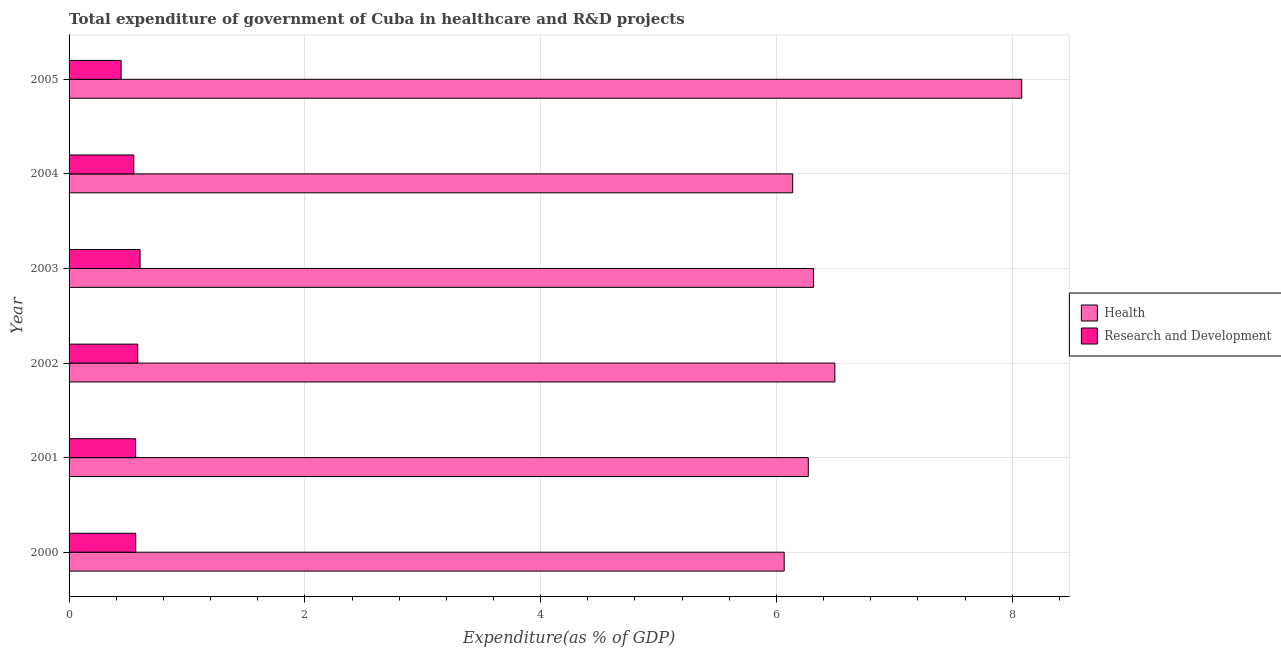How many different coloured bars are there?
Your answer should be very brief. 2. How many groups of bars are there?
Offer a terse response. 6. Are the number of bars on each tick of the Y-axis equal?
Offer a very short reply. Yes. How many bars are there on the 1st tick from the bottom?
Offer a very short reply. 2. What is the label of the 5th group of bars from the top?
Offer a terse response. 2001. What is the expenditure in r&d in 2000?
Provide a short and direct response. 0.57. Across all years, what is the maximum expenditure in r&d?
Your answer should be compact. 0.6. Across all years, what is the minimum expenditure in healthcare?
Ensure brevity in your answer.  6.07. In which year was the expenditure in r&d minimum?
Offer a very short reply. 2005. What is the total expenditure in healthcare in the graph?
Your answer should be compact. 39.36. What is the difference between the expenditure in r&d in 2000 and that in 2004?
Provide a succinct answer. 0.02. What is the difference between the expenditure in healthcare in 2000 and the expenditure in r&d in 2001?
Provide a succinct answer. 5.5. What is the average expenditure in r&d per year?
Provide a succinct answer. 0.55. In the year 2005, what is the difference between the expenditure in r&d and expenditure in healthcare?
Your answer should be compact. -7.64. In how many years, is the expenditure in r&d greater than 2.8 %?
Keep it short and to the point. 0. What is the difference between the highest and the second highest expenditure in healthcare?
Ensure brevity in your answer.  1.58. What is the difference between the highest and the lowest expenditure in healthcare?
Offer a very short reply. 2.01. Is the sum of the expenditure in healthcare in 2001 and 2003 greater than the maximum expenditure in r&d across all years?
Provide a succinct answer. Yes. What does the 2nd bar from the top in 2000 represents?
Your answer should be compact. Health. What does the 2nd bar from the bottom in 2004 represents?
Ensure brevity in your answer.  Research and Development. How many bars are there?
Offer a terse response. 12. What is the difference between two consecutive major ticks on the X-axis?
Offer a terse response. 2. Where does the legend appear in the graph?
Make the answer very short. Center right. How are the legend labels stacked?
Ensure brevity in your answer.  Vertical. What is the title of the graph?
Give a very brief answer. Total expenditure of government of Cuba in healthcare and R&D projects. Does "UN agencies" appear as one of the legend labels in the graph?
Provide a succinct answer. No. What is the label or title of the X-axis?
Ensure brevity in your answer.  Expenditure(as % of GDP). What is the Expenditure(as % of GDP) of Health in 2000?
Ensure brevity in your answer.  6.07. What is the Expenditure(as % of GDP) of Research and Development in 2000?
Offer a very short reply. 0.57. What is the Expenditure(as % of GDP) of Health in 2001?
Offer a very short reply. 6.27. What is the Expenditure(as % of GDP) in Research and Development in 2001?
Make the answer very short. 0.56. What is the Expenditure(as % of GDP) in Health in 2002?
Ensure brevity in your answer.  6.5. What is the Expenditure(as % of GDP) of Research and Development in 2002?
Make the answer very short. 0.58. What is the Expenditure(as % of GDP) of Health in 2003?
Keep it short and to the point. 6.31. What is the Expenditure(as % of GDP) of Research and Development in 2003?
Offer a terse response. 0.6. What is the Expenditure(as % of GDP) of Health in 2004?
Your answer should be compact. 6.14. What is the Expenditure(as % of GDP) of Research and Development in 2004?
Offer a terse response. 0.55. What is the Expenditure(as % of GDP) in Health in 2005?
Ensure brevity in your answer.  8.08. What is the Expenditure(as % of GDP) of Research and Development in 2005?
Offer a very short reply. 0.44. Across all years, what is the maximum Expenditure(as % of GDP) of Health?
Your answer should be very brief. 8.08. Across all years, what is the maximum Expenditure(as % of GDP) in Research and Development?
Your response must be concise. 0.6. Across all years, what is the minimum Expenditure(as % of GDP) in Health?
Keep it short and to the point. 6.07. Across all years, what is the minimum Expenditure(as % of GDP) of Research and Development?
Your answer should be very brief. 0.44. What is the total Expenditure(as % of GDP) of Health in the graph?
Make the answer very short. 39.36. What is the total Expenditure(as % of GDP) of Research and Development in the graph?
Your answer should be compact. 3.31. What is the difference between the Expenditure(as % of GDP) in Health in 2000 and that in 2001?
Your answer should be very brief. -0.2. What is the difference between the Expenditure(as % of GDP) of Research and Development in 2000 and that in 2001?
Your answer should be compact. 0. What is the difference between the Expenditure(as % of GDP) in Health in 2000 and that in 2002?
Provide a short and direct response. -0.43. What is the difference between the Expenditure(as % of GDP) in Research and Development in 2000 and that in 2002?
Make the answer very short. -0.02. What is the difference between the Expenditure(as % of GDP) in Health in 2000 and that in 2003?
Provide a succinct answer. -0.25. What is the difference between the Expenditure(as % of GDP) of Research and Development in 2000 and that in 2003?
Keep it short and to the point. -0.04. What is the difference between the Expenditure(as % of GDP) in Health in 2000 and that in 2004?
Give a very brief answer. -0.07. What is the difference between the Expenditure(as % of GDP) in Research and Development in 2000 and that in 2004?
Offer a very short reply. 0.02. What is the difference between the Expenditure(as % of GDP) in Health in 2000 and that in 2005?
Ensure brevity in your answer.  -2.01. What is the difference between the Expenditure(as % of GDP) of Research and Development in 2000 and that in 2005?
Give a very brief answer. 0.12. What is the difference between the Expenditure(as % of GDP) of Health in 2001 and that in 2002?
Provide a succinct answer. -0.23. What is the difference between the Expenditure(as % of GDP) of Research and Development in 2001 and that in 2002?
Your answer should be very brief. -0.02. What is the difference between the Expenditure(as % of GDP) of Health in 2001 and that in 2003?
Your answer should be very brief. -0.04. What is the difference between the Expenditure(as % of GDP) of Research and Development in 2001 and that in 2003?
Offer a very short reply. -0.04. What is the difference between the Expenditure(as % of GDP) in Health in 2001 and that in 2004?
Give a very brief answer. 0.13. What is the difference between the Expenditure(as % of GDP) in Research and Development in 2001 and that in 2004?
Ensure brevity in your answer.  0.02. What is the difference between the Expenditure(as % of GDP) of Health in 2001 and that in 2005?
Your answer should be compact. -1.81. What is the difference between the Expenditure(as % of GDP) in Research and Development in 2001 and that in 2005?
Give a very brief answer. 0.12. What is the difference between the Expenditure(as % of GDP) of Health in 2002 and that in 2003?
Provide a short and direct response. 0.18. What is the difference between the Expenditure(as % of GDP) of Research and Development in 2002 and that in 2003?
Offer a very short reply. -0.02. What is the difference between the Expenditure(as % of GDP) in Health in 2002 and that in 2004?
Keep it short and to the point. 0.36. What is the difference between the Expenditure(as % of GDP) of Research and Development in 2002 and that in 2004?
Ensure brevity in your answer.  0.03. What is the difference between the Expenditure(as % of GDP) in Health in 2002 and that in 2005?
Ensure brevity in your answer.  -1.59. What is the difference between the Expenditure(as % of GDP) in Research and Development in 2002 and that in 2005?
Provide a short and direct response. 0.14. What is the difference between the Expenditure(as % of GDP) in Health in 2003 and that in 2004?
Make the answer very short. 0.18. What is the difference between the Expenditure(as % of GDP) of Research and Development in 2003 and that in 2004?
Give a very brief answer. 0.05. What is the difference between the Expenditure(as % of GDP) of Health in 2003 and that in 2005?
Provide a short and direct response. -1.77. What is the difference between the Expenditure(as % of GDP) in Research and Development in 2003 and that in 2005?
Provide a succinct answer. 0.16. What is the difference between the Expenditure(as % of GDP) of Health in 2004 and that in 2005?
Give a very brief answer. -1.94. What is the difference between the Expenditure(as % of GDP) of Research and Development in 2004 and that in 2005?
Your response must be concise. 0.11. What is the difference between the Expenditure(as % of GDP) of Health in 2000 and the Expenditure(as % of GDP) of Research and Development in 2001?
Keep it short and to the point. 5.5. What is the difference between the Expenditure(as % of GDP) of Health in 2000 and the Expenditure(as % of GDP) of Research and Development in 2002?
Ensure brevity in your answer.  5.48. What is the difference between the Expenditure(as % of GDP) of Health in 2000 and the Expenditure(as % of GDP) of Research and Development in 2003?
Give a very brief answer. 5.46. What is the difference between the Expenditure(as % of GDP) in Health in 2000 and the Expenditure(as % of GDP) in Research and Development in 2004?
Provide a short and direct response. 5.52. What is the difference between the Expenditure(as % of GDP) in Health in 2000 and the Expenditure(as % of GDP) in Research and Development in 2005?
Make the answer very short. 5.62. What is the difference between the Expenditure(as % of GDP) in Health in 2001 and the Expenditure(as % of GDP) in Research and Development in 2002?
Keep it short and to the point. 5.69. What is the difference between the Expenditure(as % of GDP) in Health in 2001 and the Expenditure(as % of GDP) in Research and Development in 2003?
Provide a short and direct response. 5.67. What is the difference between the Expenditure(as % of GDP) of Health in 2001 and the Expenditure(as % of GDP) of Research and Development in 2004?
Your answer should be very brief. 5.72. What is the difference between the Expenditure(as % of GDP) in Health in 2001 and the Expenditure(as % of GDP) in Research and Development in 2005?
Give a very brief answer. 5.83. What is the difference between the Expenditure(as % of GDP) of Health in 2002 and the Expenditure(as % of GDP) of Research and Development in 2003?
Ensure brevity in your answer.  5.89. What is the difference between the Expenditure(as % of GDP) in Health in 2002 and the Expenditure(as % of GDP) in Research and Development in 2004?
Your response must be concise. 5.95. What is the difference between the Expenditure(as % of GDP) in Health in 2002 and the Expenditure(as % of GDP) in Research and Development in 2005?
Make the answer very short. 6.05. What is the difference between the Expenditure(as % of GDP) of Health in 2003 and the Expenditure(as % of GDP) of Research and Development in 2004?
Offer a terse response. 5.77. What is the difference between the Expenditure(as % of GDP) of Health in 2003 and the Expenditure(as % of GDP) of Research and Development in 2005?
Provide a short and direct response. 5.87. What is the difference between the Expenditure(as % of GDP) of Health in 2004 and the Expenditure(as % of GDP) of Research and Development in 2005?
Offer a very short reply. 5.7. What is the average Expenditure(as % of GDP) of Health per year?
Keep it short and to the point. 6.56. What is the average Expenditure(as % of GDP) of Research and Development per year?
Offer a very short reply. 0.55. In the year 2000, what is the difference between the Expenditure(as % of GDP) in Health and Expenditure(as % of GDP) in Research and Development?
Your response must be concise. 5.5. In the year 2001, what is the difference between the Expenditure(as % of GDP) in Health and Expenditure(as % of GDP) in Research and Development?
Keep it short and to the point. 5.71. In the year 2002, what is the difference between the Expenditure(as % of GDP) of Health and Expenditure(as % of GDP) of Research and Development?
Offer a very short reply. 5.91. In the year 2003, what is the difference between the Expenditure(as % of GDP) in Health and Expenditure(as % of GDP) in Research and Development?
Keep it short and to the point. 5.71. In the year 2004, what is the difference between the Expenditure(as % of GDP) of Health and Expenditure(as % of GDP) of Research and Development?
Keep it short and to the point. 5.59. In the year 2005, what is the difference between the Expenditure(as % of GDP) of Health and Expenditure(as % of GDP) of Research and Development?
Your answer should be compact. 7.64. What is the ratio of the Expenditure(as % of GDP) of Health in 2000 to that in 2001?
Provide a short and direct response. 0.97. What is the ratio of the Expenditure(as % of GDP) in Research and Development in 2000 to that in 2001?
Ensure brevity in your answer.  1. What is the ratio of the Expenditure(as % of GDP) of Health in 2000 to that in 2002?
Keep it short and to the point. 0.93. What is the ratio of the Expenditure(as % of GDP) of Research and Development in 2000 to that in 2002?
Your response must be concise. 0.97. What is the ratio of the Expenditure(as % of GDP) of Health in 2000 to that in 2003?
Give a very brief answer. 0.96. What is the ratio of the Expenditure(as % of GDP) in Research and Development in 2000 to that in 2003?
Offer a terse response. 0.94. What is the ratio of the Expenditure(as % of GDP) in Health in 2000 to that in 2004?
Keep it short and to the point. 0.99. What is the ratio of the Expenditure(as % of GDP) of Research and Development in 2000 to that in 2004?
Your answer should be compact. 1.03. What is the ratio of the Expenditure(as % of GDP) of Health in 2000 to that in 2005?
Make the answer very short. 0.75. What is the ratio of the Expenditure(as % of GDP) in Research and Development in 2000 to that in 2005?
Your answer should be compact. 1.28. What is the ratio of the Expenditure(as % of GDP) of Health in 2001 to that in 2002?
Your answer should be compact. 0.97. What is the ratio of the Expenditure(as % of GDP) in Research and Development in 2001 to that in 2002?
Make the answer very short. 0.97. What is the ratio of the Expenditure(as % of GDP) in Research and Development in 2001 to that in 2003?
Make the answer very short. 0.94. What is the ratio of the Expenditure(as % of GDP) of Health in 2001 to that in 2004?
Provide a short and direct response. 1.02. What is the ratio of the Expenditure(as % of GDP) of Research and Development in 2001 to that in 2004?
Provide a succinct answer. 1.03. What is the ratio of the Expenditure(as % of GDP) of Health in 2001 to that in 2005?
Provide a succinct answer. 0.78. What is the ratio of the Expenditure(as % of GDP) of Research and Development in 2001 to that in 2005?
Keep it short and to the point. 1.28. What is the ratio of the Expenditure(as % of GDP) of Health in 2002 to that in 2003?
Your response must be concise. 1.03. What is the ratio of the Expenditure(as % of GDP) in Research and Development in 2002 to that in 2003?
Provide a short and direct response. 0.97. What is the ratio of the Expenditure(as % of GDP) in Health in 2002 to that in 2004?
Offer a very short reply. 1.06. What is the ratio of the Expenditure(as % of GDP) of Research and Development in 2002 to that in 2004?
Keep it short and to the point. 1.06. What is the ratio of the Expenditure(as % of GDP) of Health in 2002 to that in 2005?
Keep it short and to the point. 0.8. What is the ratio of the Expenditure(as % of GDP) of Research and Development in 2002 to that in 2005?
Provide a short and direct response. 1.32. What is the ratio of the Expenditure(as % of GDP) in Health in 2003 to that in 2004?
Provide a short and direct response. 1.03. What is the ratio of the Expenditure(as % of GDP) of Research and Development in 2003 to that in 2004?
Offer a terse response. 1.1. What is the ratio of the Expenditure(as % of GDP) of Health in 2003 to that in 2005?
Provide a short and direct response. 0.78. What is the ratio of the Expenditure(as % of GDP) in Research and Development in 2003 to that in 2005?
Offer a very short reply. 1.36. What is the ratio of the Expenditure(as % of GDP) in Health in 2004 to that in 2005?
Your response must be concise. 0.76. What is the ratio of the Expenditure(as % of GDP) of Research and Development in 2004 to that in 2005?
Your answer should be very brief. 1.24. What is the difference between the highest and the second highest Expenditure(as % of GDP) in Health?
Give a very brief answer. 1.59. What is the difference between the highest and the second highest Expenditure(as % of GDP) of Research and Development?
Give a very brief answer. 0.02. What is the difference between the highest and the lowest Expenditure(as % of GDP) in Health?
Provide a short and direct response. 2.01. What is the difference between the highest and the lowest Expenditure(as % of GDP) in Research and Development?
Your answer should be compact. 0.16. 